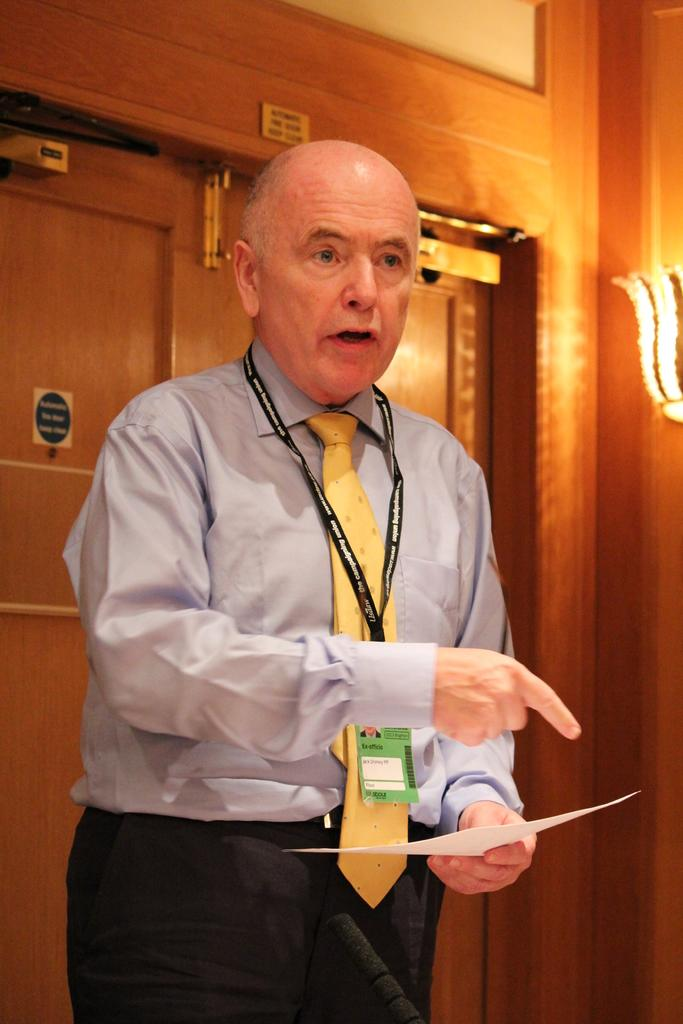What is the main subject of the image? There is a man in the image. What is the man doing in the image? The man is standing in the image. What is the man holding in his hand? The man is holding a paper in his hand. What can be seen in the background of the image? There are doors in the background of the image. What is the source of light on the right side of the image? There is a light on the wall on the right side of the image. What is present on the door in the image? There is a small sticker on the door. How does the crowd in the image react to the man's brother? There is no crowd or brother present in the image. 